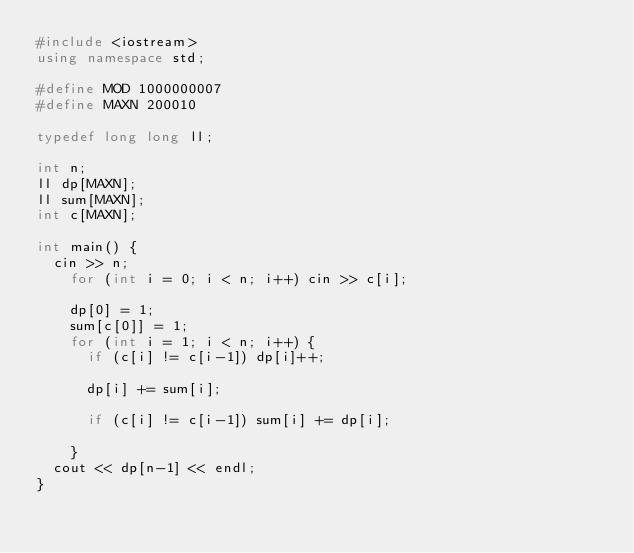Convert code to text. <code><loc_0><loc_0><loc_500><loc_500><_C++_>#include <iostream>
using namespace std;

#define MOD 1000000007
#define MAXN 200010

typedef long long ll;

int n;
ll dp[MAXN];
ll sum[MAXN];
int c[MAXN];

int main() {
	cin >> n;
  	for (int i = 0; i < n; i++) cin >> c[i];
  
    dp[0] = 1;
    sum[c[0]] = 1;
    for (int i = 1; i < n; i++) {
      if (c[i] != c[i-1]) dp[i]++;
      
      dp[i] += sum[i];
      
      if (c[i] != c[i-1]) sum[i] += dp[i];
      
    }
  cout << dp[n-1] << endl;
}
</code> 